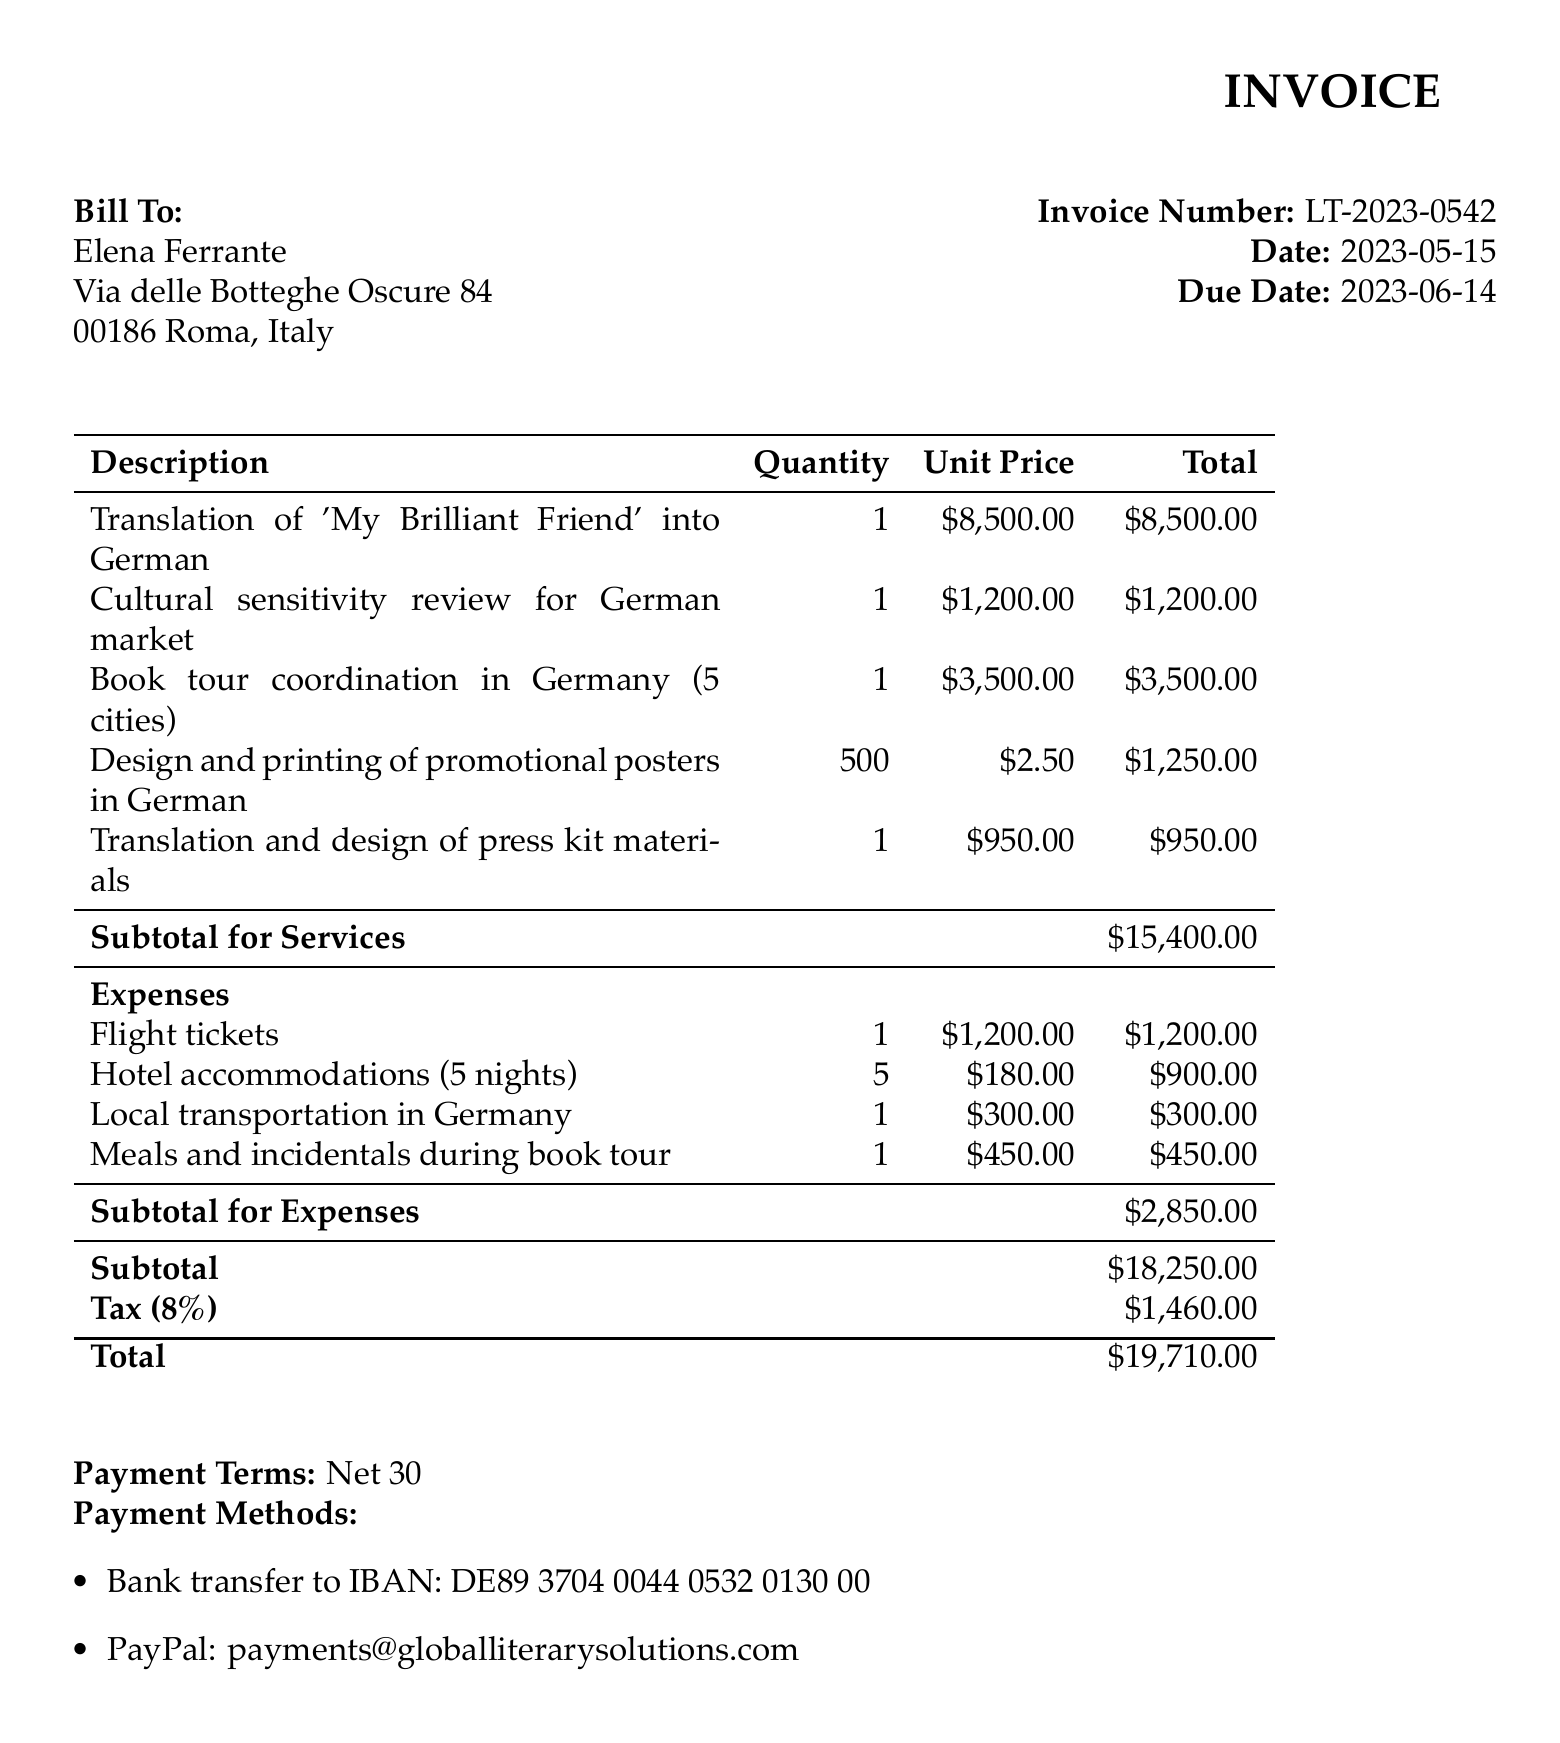What is the invoice number? The invoice number is stated clearly at the top of the document as LT-2023-0542.
Answer: LT-2023-0542 What is the due date for this invoice? The due date can be found in the document, which is specified as 2023-06-14.
Answer: 2023-06-14 Who is the client for this invoice? The client’s name is listed in the billing section of the document, which is Elena Ferrante.
Answer: Elena Ferrante What is the total amount due? The total amount is summarized at the end of the invoice as $19,710.00.
Answer: $19,710.00 How many cities are included in the book tour coordination? This detail is specified in the services section, mentioning 5 cities for the book tour.
Answer: 5 cities What is the unit price for the translation service? The document states the unit price for the translation service as $8,500.00.
Answer: $8,500.00 What method of payment is provided for PayPal? The document lists the PayPal payment method as payments@globalliterarysolutions.com.
Answer: payments@globalliterarysolutions.com What is the tax rate applied to the invoice? The tax rate is clearly indicated in the document as 8%.
Answer: 8% What type of service includes a cultural sensitivity review? This service is specifically mentioned as "Cultural sensitivity review for German market".
Answer: Cultural sensitivity review for German market 